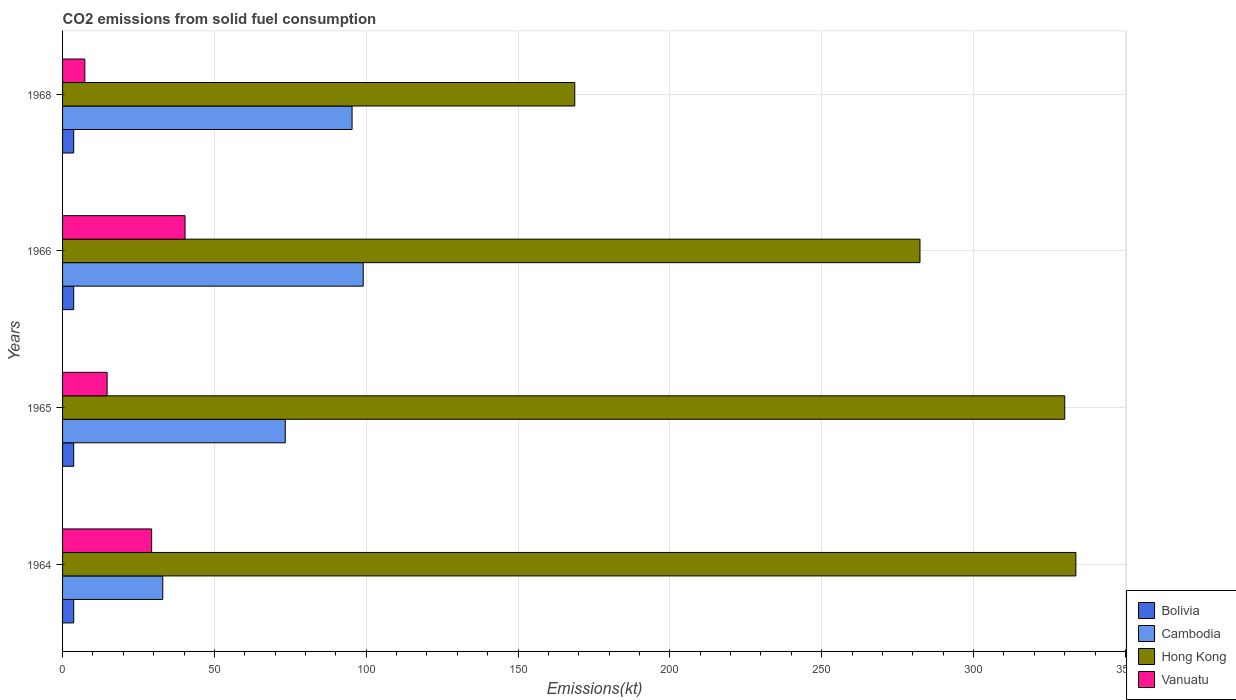How many different coloured bars are there?
Your response must be concise. 4. How many groups of bars are there?
Provide a short and direct response. 4. How many bars are there on the 1st tick from the top?
Keep it short and to the point. 4. How many bars are there on the 1st tick from the bottom?
Your response must be concise. 4. What is the label of the 4th group of bars from the top?
Your answer should be very brief. 1964. What is the amount of CO2 emitted in Vanuatu in 1965?
Make the answer very short. 14.67. Across all years, what is the maximum amount of CO2 emitted in Cambodia?
Offer a very short reply. 99.01. Across all years, what is the minimum amount of CO2 emitted in Cambodia?
Your answer should be very brief. 33. In which year was the amount of CO2 emitted in Hong Kong maximum?
Provide a short and direct response. 1964. In which year was the amount of CO2 emitted in Vanuatu minimum?
Keep it short and to the point. 1968. What is the total amount of CO2 emitted in Cambodia in the graph?
Give a very brief answer. 300.69. What is the difference between the amount of CO2 emitted in Bolivia in 1965 and that in 1968?
Offer a very short reply. 0. What is the difference between the amount of CO2 emitted in Hong Kong in 1966 and the amount of CO2 emitted in Vanuatu in 1964?
Ensure brevity in your answer.  253.02. What is the average amount of CO2 emitted in Cambodia per year?
Provide a succinct answer. 75.17. In the year 1965, what is the difference between the amount of CO2 emitted in Hong Kong and amount of CO2 emitted in Vanuatu?
Make the answer very short. 315.36. In how many years, is the amount of CO2 emitted in Bolivia greater than 130 kt?
Offer a very short reply. 0. What is the ratio of the amount of CO2 emitted in Cambodia in 1965 to that in 1968?
Your response must be concise. 0.77. What is the difference between the highest and the second highest amount of CO2 emitted in Vanuatu?
Your response must be concise. 11. What is the difference between the highest and the lowest amount of CO2 emitted in Vanuatu?
Keep it short and to the point. 33. In how many years, is the amount of CO2 emitted in Hong Kong greater than the average amount of CO2 emitted in Hong Kong taken over all years?
Provide a succinct answer. 3. Is the sum of the amount of CO2 emitted in Bolivia in 1966 and 1968 greater than the maximum amount of CO2 emitted in Cambodia across all years?
Your response must be concise. No. Is it the case that in every year, the sum of the amount of CO2 emitted in Cambodia and amount of CO2 emitted in Bolivia is greater than the sum of amount of CO2 emitted in Hong Kong and amount of CO2 emitted in Vanuatu?
Ensure brevity in your answer.  No. What does the 2nd bar from the top in 1966 represents?
Ensure brevity in your answer.  Hong Kong. What does the 3rd bar from the bottom in 1968 represents?
Provide a succinct answer. Hong Kong. How many bars are there?
Offer a terse response. 16. Are all the bars in the graph horizontal?
Ensure brevity in your answer.  Yes. How many years are there in the graph?
Your answer should be compact. 4. Does the graph contain any zero values?
Give a very brief answer. No. Where does the legend appear in the graph?
Provide a succinct answer. Bottom right. How many legend labels are there?
Your response must be concise. 4. What is the title of the graph?
Make the answer very short. CO2 emissions from solid fuel consumption. What is the label or title of the X-axis?
Keep it short and to the point. Emissions(kt). What is the Emissions(kt) in Bolivia in 1964?
Your answer should be very brief. 3.67. What is the Emissions(kt) of Cambodia in 1964?
Keep it short and to the point. 33. What is the Emissions(kt) of Hong Kong in 1964?
Your response must be concise. 333.7. What is the Emissions(kt) in Vanuatu in 1964?
Ensure brevity in your answer.  29.34. What is the Emissions(kt) in Bolivia in 1965?
Make the answer very short. 3.67. What is the Emissions(kt) of Cambodia in 1965?
Make the answer very short. 73.34. What is the Emissions(kt) of Hong Kong in 1965?
Ensure brevity in your answer.  330.03. What is the Emissions(kt) in Vanuatu in 1965?
Offer a terse response. 14.67. What is the Emissions(kt) in Bolivia in 1966?
Offer a very short reply. 3.67. What is the Emissions(kt) in Cambodia in 1966?
Offer a very short reply. 99.01. What is the Emissions(kt) of Hong Kong in 1966?
Offer a very short reply. 282.36. What is the Emissions(kt) of Vanuatu in 1966?
Offer a very short reply. 40.34. What is the Emissions(kt) in Bolivia in 1968?
Your answer should be compact. 3.67. What is the Emissions(kt) in Cambodia in 1968?
Offer a terse response. 95.34. What is the Emissions(kt) in Hong Kong in 1968?
Provide a succinct answer. 168.68. What is the Emissions(kt) in Vanuatu in 1968?
Offer a terse response. 7.33. Across all years, what is the maximum Emissions(kt) of Bolivia?
Offer a terse response. 3.67. Across all years, what is the maximum Emissions(kt) of Cambodia?
Your response must be concise. 99.01. Across all years, what is the maximum Emissions(kt) in Hong Kong?
Provide a short and direct response. 333.7. Across all years, what is the maximum Emissions(kt) in Vanuatu?
Offer a terse response. 40.34. Across all years, what is the minimum Emissions(kt) in Bolivia?
Offer a terse response. 3.67. Across all years, what is the minimum Emissions(kt) in Cambodia?
Keep it short and to the point. 33. Across all years, what is the minimum Emissions(kt) of Hong Kong?
Your response must be concise. 168.68. Across all years, what is the minimum Emissions(kt) in Vanuatu?
Your answer should be very brief. 7.33. What is the total Emissions(kt) of Bolivia in the graph?
Provide a short and direct response. 14.67. What is the total Emissions(kt) of Cambodia in the graph?
Provide a short and direct response. 300.69. What is the total Emissions(kt) of Hong Kong in the graph?
Offer a very short reply. 1114.77. What is the total Emissions(kt) in Vanuatu in the graph?
Offer a terse response. 91.67. What is the difference between the Emissions(kt) in Cambodia in 1964 and that in 1965?
Provide a succinct answer. -40.34. What is the difference between the Emissions(kt) in Hong Kong in 1964 and that in 1965?
Provide a short and direct response. 3.67. What is the difference between the Emissions(kt) in Vanuatu in 1964 and that in 1965?
Provide a succinct answer. 14.67. What is the difference between the Emissions(kt) of Bolivia in 1964 and that in 1966?
Your response must be concise. 0. What is the difference between the Emissions(kt) of Cambodia in 1964 and that in 1966?
Provide a succinct answer. -66.01. What is the difference between the Emissions(kt) of Hong Kong in 1964 and that in 1966?
Offer a very short reply. 51.34. What is the difference between the Emissions(kt) of Vanuatu in 1964 and that in 1966?
Keep it short and to the point. -11. What is the difference between the Emissions(kt) of Bolivia in 1964 and that in 1968?
Make the answer very short. 0. What is the difference between the Emissions(kt) in Cambodia in 1964 and that in 1968?
Provide a short and direct response. -62.34. What is the difference between the Emissions(kt) of Hong Kong in 1964 and that in 1968?
Offer a terse response. 165.01. What is the difference between the Emissions(kt) of Vanuatu in 1964 and that in 1968?
Give a very brief answer. 22. What is the difference between the Emissions(kt) of Cambodia in 1965 and that in 1966?
Keep it short and to the point. -25.67. What is the difference between the Emissions(kt) in Hong Kong in 1965 and that in 1966?
Your answer should be compact. 47.67. What is the difference between the Emissions(kt) of Vanuatu in 1965 and that in 1966?
Offer a terse response. -25.67. What is the difference between the Emissions(kt) in Cambodia in 1965 and that in 1968?
Offer a terse response. -22. What is the difference between the Emissions(kt) of Hong Kong in 1965 and that in 1968?
Make the answer very short. 161.35. What is the difference between the Emissions(kt) in Vanuatu in 1965 and that in 1968?
Provide a succinct answer. 7.33. What is the difference between the Emissions(kt) of Cambodia in 1966 and that in 1968?
Make the answer very short. 3.67. What is the difference between the Emissions(kt) of Hong Kong in 1966 and that in 1968?
Provide a short and direct response. 113.68. What is the difference between the Emissions(kt) of Vanuatu in 1966 and that in 1968?
Your answer should be very brief. 33. What is the difference between the Emissions(kt) in Bolivia in 1964 and the Emissions(kt) in Cambodia in 1965?
Provide a succinct answer. -69.67. What is the difference between the Emissions(kt) of Bolivia in 1964 and the Emissions(kt) of Hong Kong in 1965?
Your answer should be very brief. -326.36. What is the difference between the Emissions(kt) of Bolivia in 1964 and the Emissions(kt) of Vanuatu in 1965?
Ensure brevity in your answer.  -11. What is the difference between the Emissions(kt) in Cambodia in 1964 and the Emissions(kt) in Hong Kong in 1965?
Offer a very short reply. -297.03. What is the difference between the Emissions(kt) of Cambodia in 1964 and the Emissions(kt) of Vanuatu in 1965?
Ensure brevity in your answer.  18.34. What is the difference between the Emissions(kt) in Hong Kong in 1964 and the Emissions(kt) in Vanuatu in 1965?
Offer a very short reply. 319.03. What is the difference between the Emissions(kt) of Bolivia in 1964 and the Emissions(kt) of Cambodia in 1966?
Provide a succinct answer. -95.34. What is the difference between the Emissions(kt) of Bolivia in 1964 and the Emissions(kt) of Hong Kong in 1966?
Offer a very short reply. -278.69. What is the difference between the Emissions(kt) of Bolivia in 1964 and the Emissions(kt) of Vanuatu in 1966?
Your answer should be very brief. -36.67. What is the difference between the Emissions(kt) in Cambodia in 1964 and the Emissions(kt) in Hong Kong in 1966?
Your response must be concise. -249.36. What is the difference between the Emissions(kt) in Cambodia in 1964 and the Emissions(kt) in Vanuatu in 1966?
Offer a terse response. -7.33. What is the difference between the Emissions(kt) in Hong Kong in 1964 and the Emissions(kt) in Vanuatu in 1966?
Provide a succinct answer. 293.36. What is the difference between the Emissions(kt) of Bolivia in 1964 and the Emissions(kt) of Cambodia in 1968?
Make the answer very short. -91.67. What is the difference between the Emissions(kt) in Bolivia in 1964 and the Emissions(kt) in Hong Kong in 1968?
Provide a short and direct response. -165.01. What is the difference between the Emissions(kt) in Bolivia in 1964 and the Emissions(kt) in Vanuatu in 1968?
Make the answer very short. -3.67. What is the difference between the Emissions(kt) of Cambodia in 1964 and the Emissions(kt) of Hong Kong in 1968?
Provide a succinct answer. -135.68. What is the difference between the Emissions(kt) in Cambodia in 1964 and the Emissions(kt) in Vanuatu in 1968?
Ensure brevity in your answer.  25.67. What is the difference between the Emissions(kt) in Hong Kong in 1964 and the Emissions(kt) in Vanuatu in 1968?
Make the answer very short. 326.36. What is the difference between the Emissions(kt) in Bolivia in 1965 and the Emissions(kt) in Cambodia in 1966?
Your response must be concise. -95.34. What is the difference between the Emissions(kt) in Bolivia in 1965 and the Emissions(kt) in Hong Kong in 1966?
Provide a succinct answer. -278.69. What is the difference between the Emissions(kt) of Bolivia in 1965 and the Emissions(kt) of Vanuatu in 1966?
Ensure brevity in your answer.  -36.67. What is the difference between the Emissions(kt) of Cambodia in 1965 and the Emissions(kt) of Hong Kong in 1966?
Make the answer very short. -209.02. What is the difference between the Emissions(kt) in Cambodia in 1965 and the Emissions(kt) in Vanuatu in 1966?
Provide a short and direct response. 33. What is the difference between the Emissions(kt) in Hong Kong in 1965 and the Emissions(kt) in Vanuatu in 1966?
Provide a short and direct response. 289.69. What is the difference between the Emissions(kt) of Bolivia in 1965 and the Emissions(kt) of Cambodia in 1968?
Offer a terse response. -91.67. What is the difference between the Emissions(kt) of Bolivia in 1965 and the Emissions(kt) of Hong Kong in 1968?
Provide a succinct answer. -165.01. What is the difference between the Emissions(kt) of Bolivia in 1965 and the Emissions(kt) of Vanuatu in 1968?
Provide a short and direct response. -3.67. What is the difference between the Emissions(kt) in Cambodia in 1965 and the Emissions(kt) in Hong Kong in 1968?
Offer a terse response. -95.34. What is the difference between the Emissions(kt) in Cambodia in 1965 and the Emissions(kt) in Vanuatu in 1968?
Ensure brevity in your answer.  66.01. What is the difference between the Emissions(kt) of Hong Kong in 1965 and the Emissions(kt) of Vanuatu in 1968?
Ensure brevity in your answer.  322.7. What is the difference between the Emissions(kt) of Bolivia in 1966 and the Emissions(kt) of Cambodia in 1968?
Your answer should be very brief. -91.67. What is the difference between the Emissions(kt) in Bolivia in 1966 and the Emissions(kt) in Hong Kong in 1968?
Give a very brief answer. -165.01. What is the difference between the Emissions(kt) of Bolivia in 1966 and the Emissions(kt) of Vanuatu in 1968?
Ensure brevity in your answer.  -3.67. What is the difference between the Emissions(kt) in Cambodia in 1966 and the Emissions(kt) in Hong Kong in 1968?
Give a very brief answer. -69.67. What is the difference between the Emissions(kt) of Cambodia in 1966 and the Emissions(kt) of Vanuatu in 1968?
Offer a terse response. 91.67. What is the difference between the Emissions(kt) in Hong Kong in 1966 and the Emissions(kt) in Vanuatu in 1968?
Give a very brief answer. 275.02. What is the average Emissions(kt) of Bolivia per year?
Ensure brevity in your answer.  3.67. What is the average Emissions(kt) of Cambodia per year?
Your response must be concise. 75.17. What is the average Emissions(kt) of Hong Kong per year?
Ensure brevity in your answer.  278.69. What is the average Emissions(kt) in Vanuatu per year?
Keep it short and to the point. 22.92. In the year 1964, what is the difference between the Emissions(kt) in Bolivia and Emissions(kt) in Cambodia?
Keep it short and to the point. -29.34. In the year 1964, what is the difference between the Emissions(kt) in Bolivia and Emissions(kt) in Hong Kong?
Make the answer very short. -330.03. In the year 1964, what is the difference between the Emissions(kt) of Bolivia and Emissions(kt) of Vanuatu?
Your answer should be very brief. -25.67. In the year 1964, what is the difference between the Emissions(kt) in Cambodia and Emissions(kt) in Hong Kong?
Give a very brief answer. -300.69. In the year 1964, what is the difference between the Emissions(kt) of Cambodia and Emissions(kt) of Vanuatu?
Your answer should be compact. 3.67. In the year 1964, what is the difference between the Emissions(kt) in Hong Kong and Emissions(kt) in Vanuatu?
Make the answer very short. 304.36. In the year 1965, what is the difference between the Emissions(kt) of Bolivia and Emissions(kt) of Cambodia?
Keep it short and to the point. -69.67. In the year 1965, what is the difference between the Emissions(kt) of Bolivia and Emissions(kt) of Hong Kong?
Ensure brevity in your answer.  -326.36. In the year 1965, what is the difference between the Emissions(kt) of Bolivia and Emissions(kt) of Vanuatu?
Provide a succinct answer. -11. In the year 1965, what is the difference between the Emissions(kt) of Cambodia and Emissions(kt) of Hong Kong?
Give a very brief answer. -256.69. In the year 1965, what is the difference between the Emissions(kt) of Cambodia and Emissions(kt) of Vanuatu?
Make the answer very short. 58.67. In the year 1965, what is the difference between the Emissions(kt) of Hong Kong and Emissions(kt) of Vanuatu?
Your response must be concise. 315.36. In the year 1966, what is the difference between the Emissions(kt) in Bolivia and Emissions(kt) in Cambodia?
Give a very brief answer. -95.34. In the year 1966, what is the difference between the Emissions(kt) in Bolivia and Emissions(kt) in Hong Kong?
Your answer should be compact. -278.69. In the year 1966, what is the difference between the Emissions(kt) in Bolivia and Emissions(kt) in Vanuatu?
Ensure brevity in your answer.  -36.67. In the year 1966, what is the difference between the Emissions(kt) of Cambodia and Emissions(kt) of Hong Kong?
Keep it short and to the point. -183.35. In the year 1966, what is the difference between the Emissions(kt) of Cambodia and Emissions(kt) of Vanuatu?
Provide a short and direct response. 58.67. In the year 1966, what is the difference between the Emissions(kt) of Hong Kong and Emissions(kt) of Vanuatu?
Give a very brief answer. 242.02. In the year 1968, what is the difference between the Emissions(kt) of Bolivia and Emissions(kt) of Cambodia?
Ensure brevity in your answer.  -91.67. In the year 1968, what is the difference between the Emissions(kt) of Bolivia and Emissions(kt) of Hong Kong?
Make the answer very short. -165.01. In the year 1968, what is the difference between the Emissions(kt) in Bolivia and Emissions(kt) in Vanuatu?
Keep it short and to the point. -3.67. In the year 1968, what is the difference between the Emissions(kt) of Cambodia and Emissions(kt) of Hong Kong?
Provide a succinct answer. -73.34. In the year 1968, what is the difference between the Emissions(kt) of Cambodia and Emissions(kt) of Vanuatu?
Your answer should be compact. 88.01. In the year 1968, what is the difference between the Emissions(kt) in Hong Kong and Emissions(kt) in Vanuatu?
Provide a succinct answer. 161.35. What is the ratio of the Emissions(kt) of Bolivia in 1964 to that in 1965?
Keep it short and to the point. 1. What is the ratio of the Emissions(kt) in Cambodia in 1964 to that in 1965?
Offer a terse response. 0.45. What is the ratio of the Emissions(kt) of Hong Kong in 1964 to that in 1965?
Your answer should be very brief. 1.01. What is the ratio of the Emissions(kt) in Vanuatu in 1964 to that in 1965?
Offer a terse response. 2. What is the ratio of the Emissions(kt) in Hong Kong in 1964 to that in 1966?
Keep it short and to the point. 1.18. What is the ratio of the Emissions(kt) in Vanuatu in 1964 to that in 1966?
Keep it short and to the point. 0.73. What is the ratio of the Emissions(kt) in Cambodia in 1964 to that in 1968?
Give a very brief answer. 0.35. What is the ratio of the Emissions(kt) in Hong Kong in 1964 to that in 1968?
Provide a short and direct response. 1.98. What is the ratio of the Emissions(kt) in Cambodia in 1965 to that in 1966?
Provide a succinct answer. 0.74. What is the ratio of the Emissions(kt) of Hong Kong in 1965 to that in 1966?
Your answer should be very brief. 1.17. What is the ratio of the Emissions(kt) of Vanuatu in 1965 to that in 1966?
Offer a very short reply. 0.36. What is the ratio of the Emissions(kt) of Bolivia in 1965 to that in 1968?
Offer a terse response. 1. What is the ratio of the Emissions(kt) in Cambodia in 1965 to that in 1968?
Offer a terse response. 0.77. What is the ratio of the Emissions(kt) in Hong Kong in 1965 to that in 1968?
Your response must be concise. 1.96. What is the ratio of the Emissions(kt) of Vanuatu in 1965 to that in 1968?
Offer a very short reply. 2. What is the ratio of the Emissions(kt) of Hong Kong in 1966 to that in 1968?
Make the answer very short. 1.67. What is the difference between the highest and the second highest Emissions(kt) of Cambodia?
Make the answer very short. 3.67. What is the difference between the highest and the second highest Emissions(kt) of Hong Kong?
Offer a very short reply. 3.67. What is the difference between the highest and the second highest Emissions(kt) of Vanuatu?
Keep it short and to the point. 11. What is the difference between the highest and the lowest Emissions(kt) in Bolivia?
Provide a succinct answer. 0. What is the difference between the highest and the lowest Emissions(kt) in Cambodia?
Offer a terse response. 66.01. What is the difference between the highest and the lowest Emissions(kt) in Hong Kong?
Make the answer very short. 165.01. What is the difference between the highest and the lowest Emissions(kt) in Vanuatu?
Provide a short and direct response. 33. 